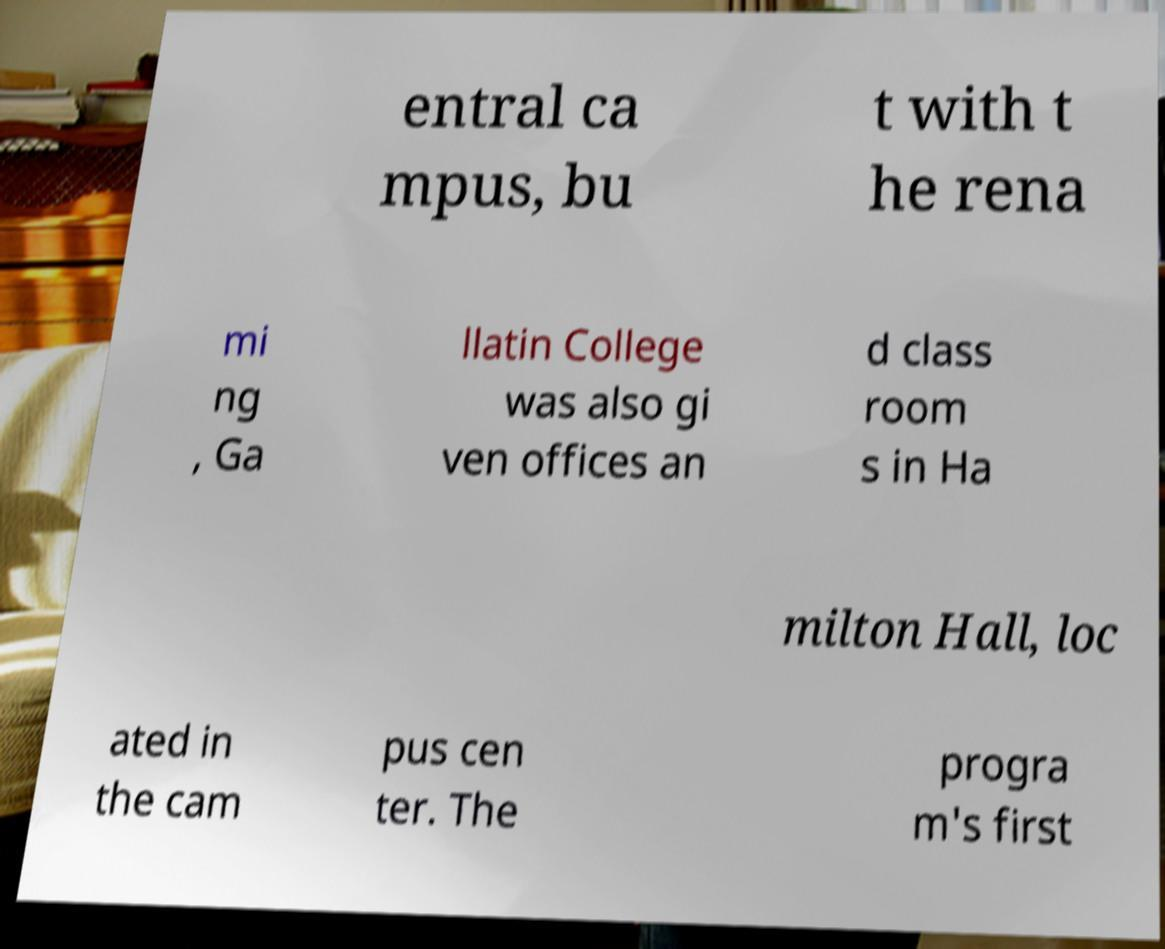For documentation purposes, I need the text within this image transcribed. Could you provide that? entral ca mpus, bu t with t he rena mi ng , Ga llatin College was also gi ven offices an d class room s in Ha milton Hall, loc ated in the cam pus cen ter. The progra m's first 